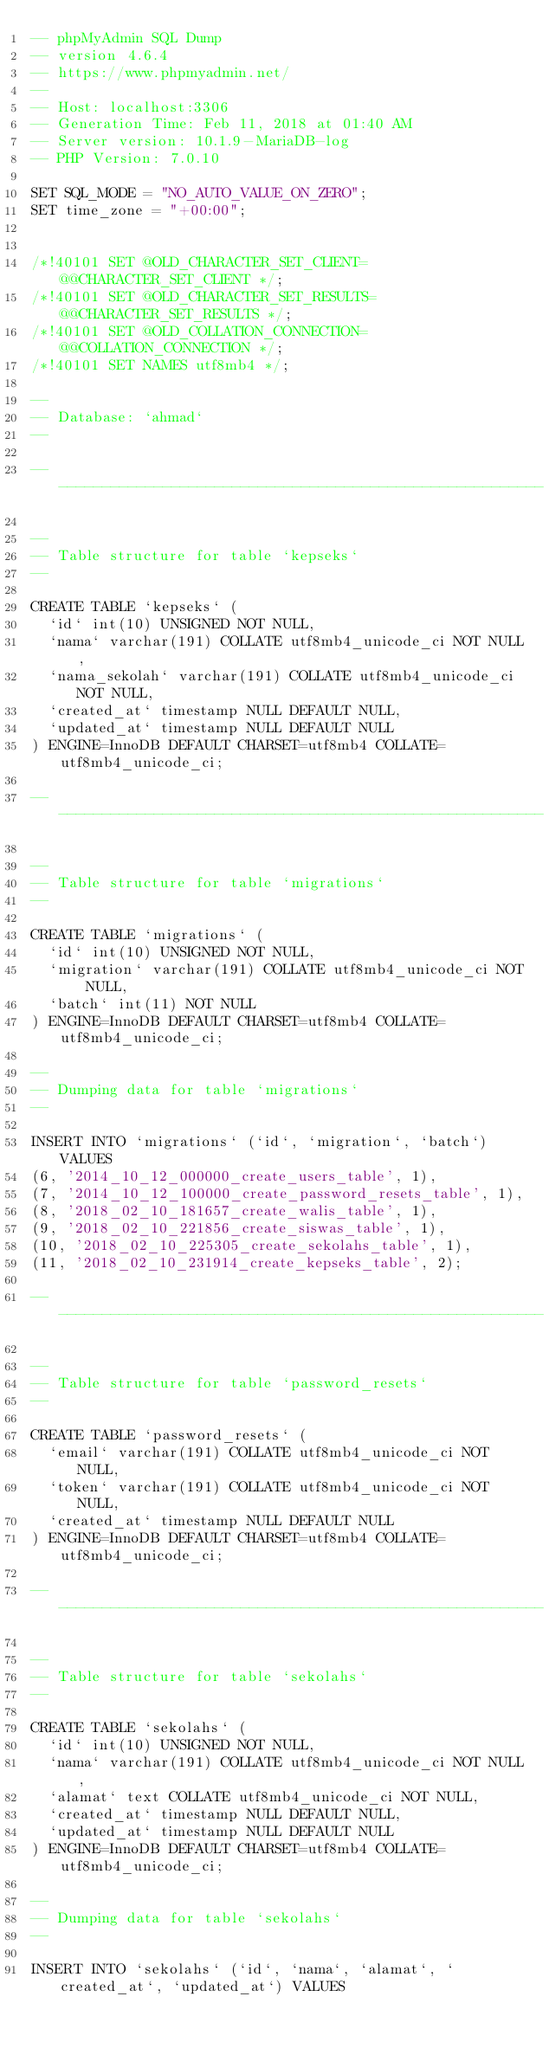Convert code to text. <code><loc_0><loc_0><loc_500><loc_500><_SQL_>-- phpMyAdmin SQL Dump
-- version 4.6.4
-- https://www.phpmyadmin.net/
--
-- Host: localhost:3306
-- Generation Time: Feb 11, 2018 at 01:40 AM
-- Server version: 10.1.9-MariaDB-log
-- PHP Version: 7.0.10

SET SQL_MODE = "NO_AUTO_VALUE_ON_ZERO";
SET time_zone = "+00:00";


/*!40101 SET @OLD_CHARACTER_SET_CLIENT=@@CHARACTER_SET_CLIENT */;
/*!40101 SET @OLD_CHARACTER_SET_RESULTS=@@CHARACTER_SET_RESULTS */;
/*!40101 SET @OLD_COLLATION_CONNECTION=@@COLLATION_CONNECTION */;
/*!40101 SET NAMES utf8mb4 */;

--
-- Database: `ahmad`
--

-- --------------------------------------------------------

--
-- Table structure for table `kepseks`
--

CREATE TABLE `kepseks` (
  `id` int(10) UNSIGNED NOT NULL,
  `nama` varchar(191) COLLATE utf8mb4_unicode_ci NOT NULL,
  `nama_sekolah` varchar(191) COLLATE utf8mb4_unicode_ci NOT NULL,
  `created_at` timestamp NULL DEFAULT NULL,
  `updated_at` timestamp NULL DEFAULT NULL
) ENGINE=InnoDB DEFAULT CHARSET=utf8mb4 COLLATE=utf8mb4_unicode_ci;

-- --------------------------------------------------------

--
-- Table structure for table `migrations`
--

CREATE TABLE `migrations` (
  `id` int(10) UNSIGNED NOT NULL,
  `migration` varchar(191) COLLATE utf8mb4_unicode_ci NOT NULL,
  `batch` int(11) NOT NULL
) ENGINE=InnoDB DEFAULT CHARSET=utf8mb4 COLLATE=utf8mb4_unicode_ci;

--
-- Dumping data for table `migrations`
--

INSERT INTO `migrations` (`id`, `migration`, `batch`) VALUES
(6, '2014_10_12_000000_create_users_table', 1),
(7, '2014_10_12_100000_create_password_resets_table', 1),
(8, '2018_02_10_181657_create_walis_table', 1),
(9, '2018_02_10_221856_create_siswas_table', 1),
(10, '2018_02_10_225305_create_sekolahs_table', 1),
(11, '2018_02_10_231914_create_kepseks_table', 2);

-- --------------------------------------------------------

--
-- Table structure for table `password_resets`
--

CREATE TABLE `password_resets` (
  `email` varchar(191) COLLATE utf8mb4_unicode_ci NOT NULL,
  `token` varchar(191) COLLATE utf8mb4_unicode_ci NOT NULL,
  `created_at` timestamp NULL DEFAULT NULL
) ENGINE=InnoDB DEFAULT CHARSET=utf8mb4 COLLATE=utf8mb4_unicode_ci;

-- --------------------------------------------------------

--
-- Table structure for table `sekolahs`
--

CREATE TABLE `sekolahs` (
  `id` int(10) UNSIGNED NOT NULL,
  `nama` varchar(191) COLLATE utf8mb4_unicode_ci NOT NULL,
  `alamat` text COLLATE utf8mb4_unicode_ci NOT NULL,
  `created_at` timestamp NULL DEFAULT NULL,
  `updated_at` timestamp NULL DEFAULT NULL
) ENGINE=InnoDB DEFAULT CHARSET=utf8mb4 COLLATE=utf8mb4_unicode_ci;

--
-- Dumping data for table `sekolahs`
--

INSERT INTO `sekolahs` (`id`, `nama`, `alamat`, `created_at`, `updated_at`) VALUES</code> 